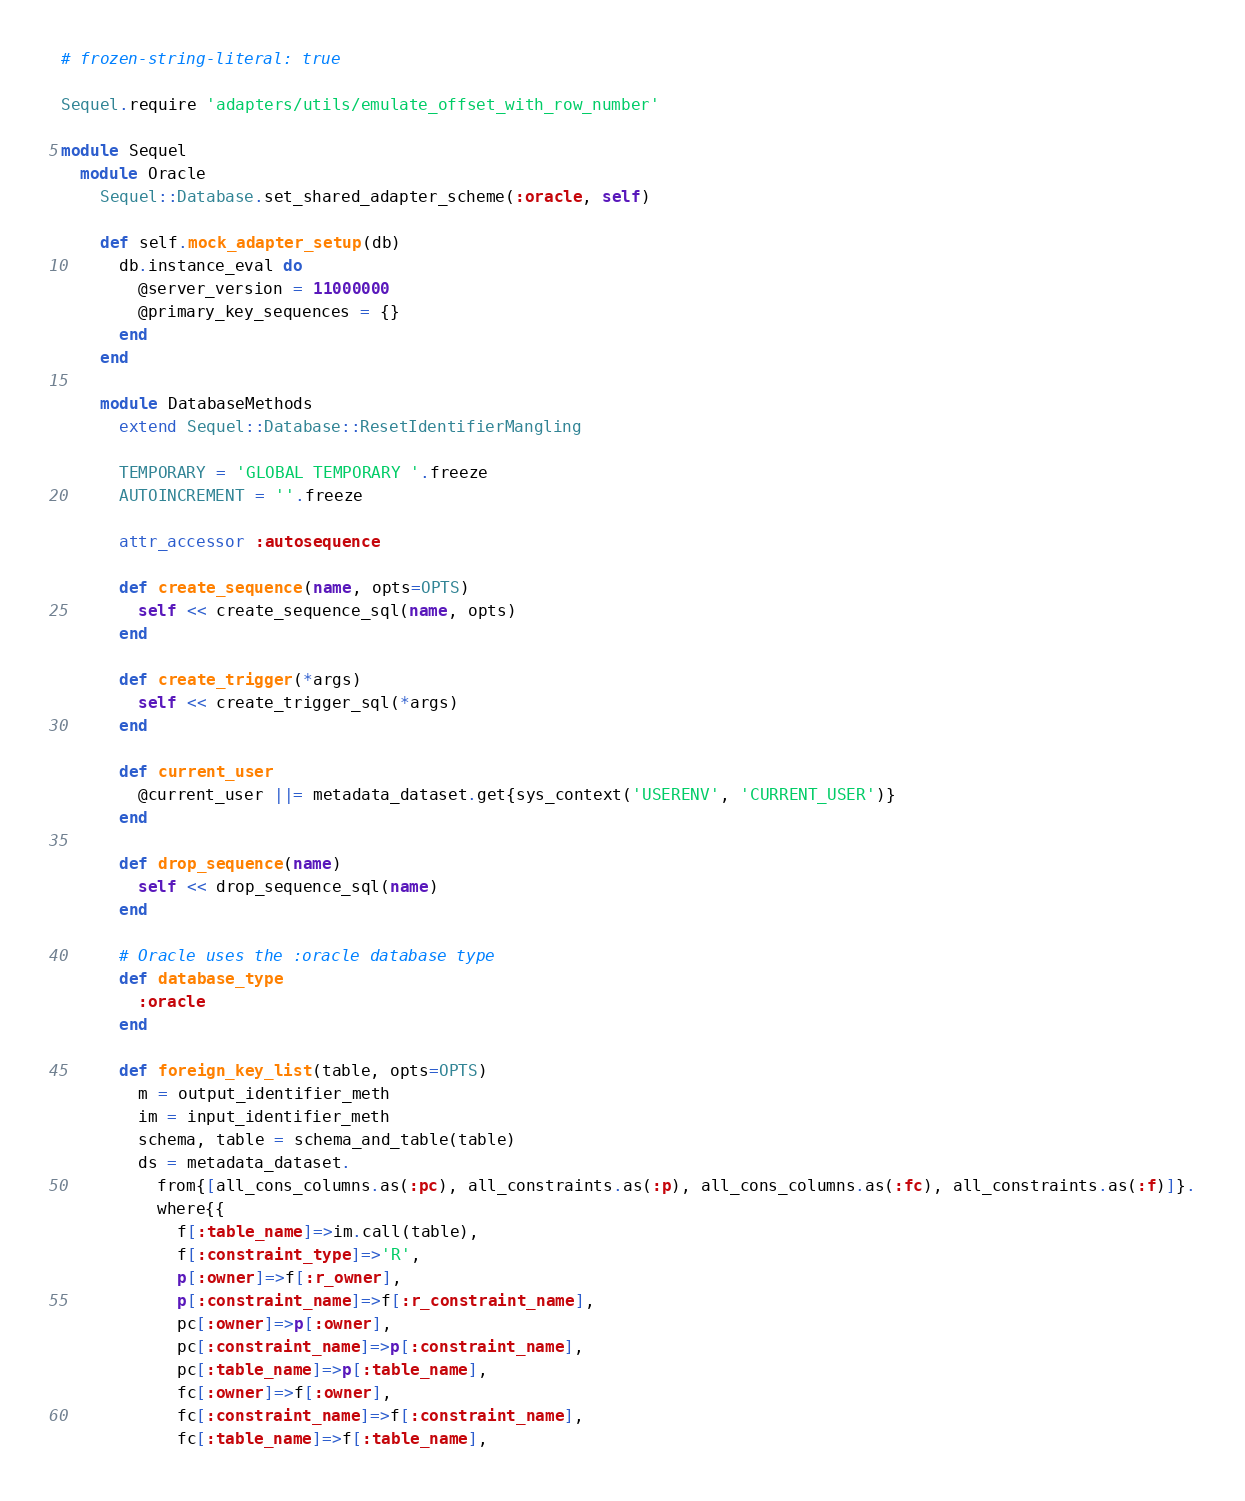Convert code to text. <code><loc_0><loc_0><loc_500><loc_500><_Ruby_># frozen-string-literal: true

Sequel.require 'adapters/utils/emulate_offset_with_row_number'

module Sequel
  module Oracle
    Sequel::Database.set_shared_adapter_scheme(:oracle, self)
    
    def self.mock_adapter_setup(db)
      db.instance_eval do
        @server_version = 11000000
        @primary_key_sequences = {}
      end
    end

    module DatabaseMethods
      extend Sequel::Database::ResetIdentifierMangling

      TEMPORARY = 'GLOBAL TEMPORARY '.freeze
      AUTOINCREMENT = ''.freeze

      attr_accessor :autosequence

      def create_sequence(name, opts=OPTS)
        self << create_sequence_sql(name, opts)
      end

      def create_trigger(*args)
        self << create_trigger_sql(*args)
      end

      def current_user
        @current_user ||= metadata_dataset.get{sys_context('USERENV', 'CURRENT_USER')}
      end

      def drop_sequence(name)
        self << drop_sequence_sql(name)
      end

      # Oracle uses the :oracle database type
      def database_type
        :oracle
      end

      def foreign_key_list(table, opts=OPTS)
        m = output_identifier_meth
        im = input_identifier_meth
        schema, table = schema_and_table(table)
        ds = metadata_dataset.
          from{[all_cons_columns.as(:pc), all_constraints.as(:p), all_cons_columns.as(:fc), all_constraints.as(:f)]}.
          where{{
            f[:table_name]=>im.call(table),
            f[:constraint_type]=>'R',
            p[:owner]=>f[:r_owner],
            p[:constraint_name]=>f[:r_constraint_name],
            pc[:owner]=>p[:owner],
            pc[:constraint_name]=>p[:constraint_name],
            pc[:table_name]=>p[:table_name],
            fc[:owner]=>f[:owner],
            fc[:constraint_name]=>f[:constraint_name],
            fc[:table_name]=>f[:table_name],</code> 